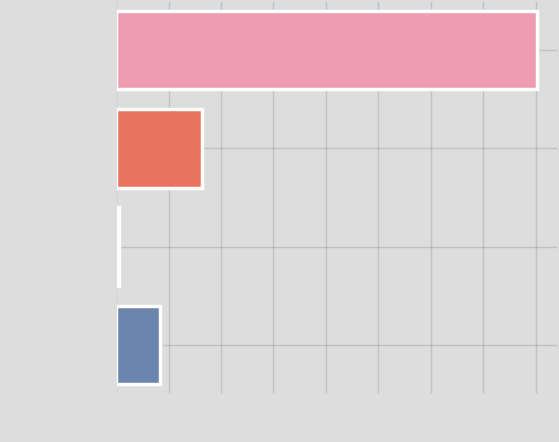Convert chart to OTSL. <chart><loc_0><loc_0><loc_500><loc_500><bar_chart><fcel>(for the year ended December<fcel>Customer-related<fcel>Fair value adjustment on<fcel>Total amortization expense<nl><fcel>2005<fcel>410.6<fcel>12<fcel>211.3<nl></chart> 